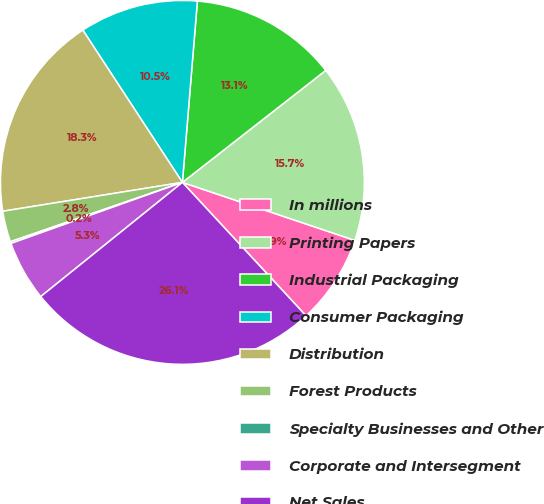Convert chart to OTSL. <chart><loc_0><loc_0><loc_500><loc_500><pie_chart><fcel>In millions<fcel>Printing Papers<fcel>Industrial Packaging<fcel>Consumer Packaging<fcel>Distribution<fcel>Forest Products<fcel>Specialty Businesses and Other<fcel>Corporate and Intersegment<fcel>Net Sales<nl><fcel>7.94%<fcel>15.72%<fcel>13.13%<fcel>10.53%<fcel>18.32%<fcel>2.75%<fcel>0.16%<fcel>5.35%<fcel>26.1%<nl></chart> 